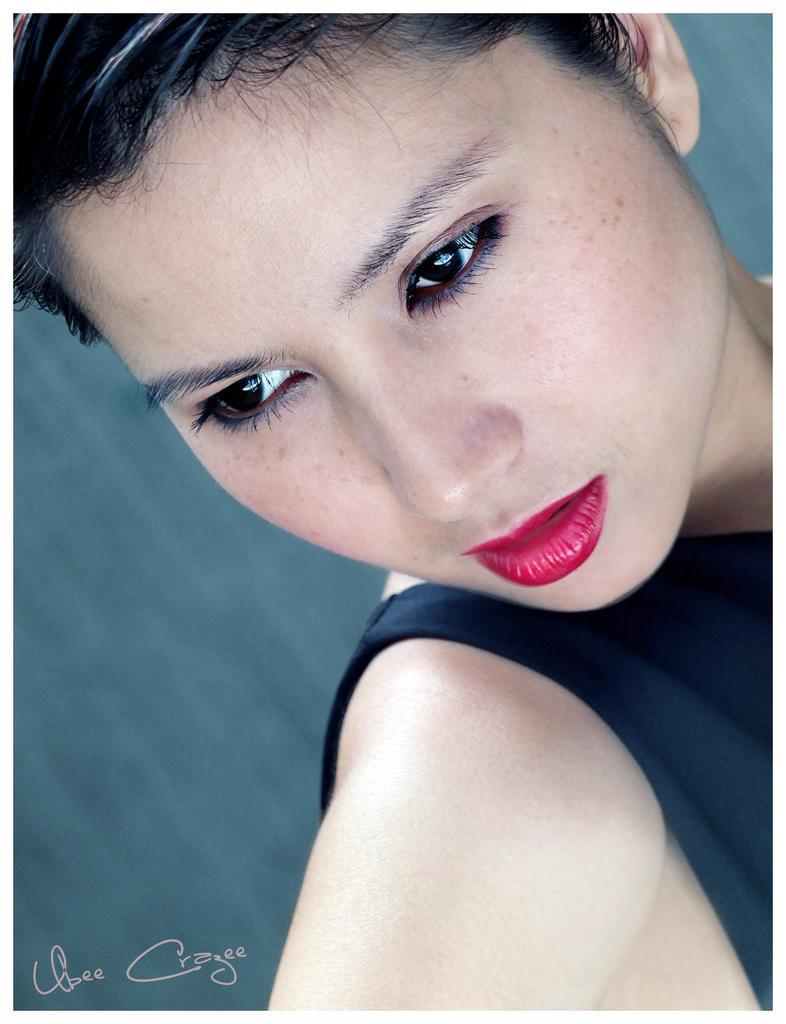In one or two sentences, can you explain what this image depicts? In the center of the image, we can see a lady and at the bottom, there is some text. 